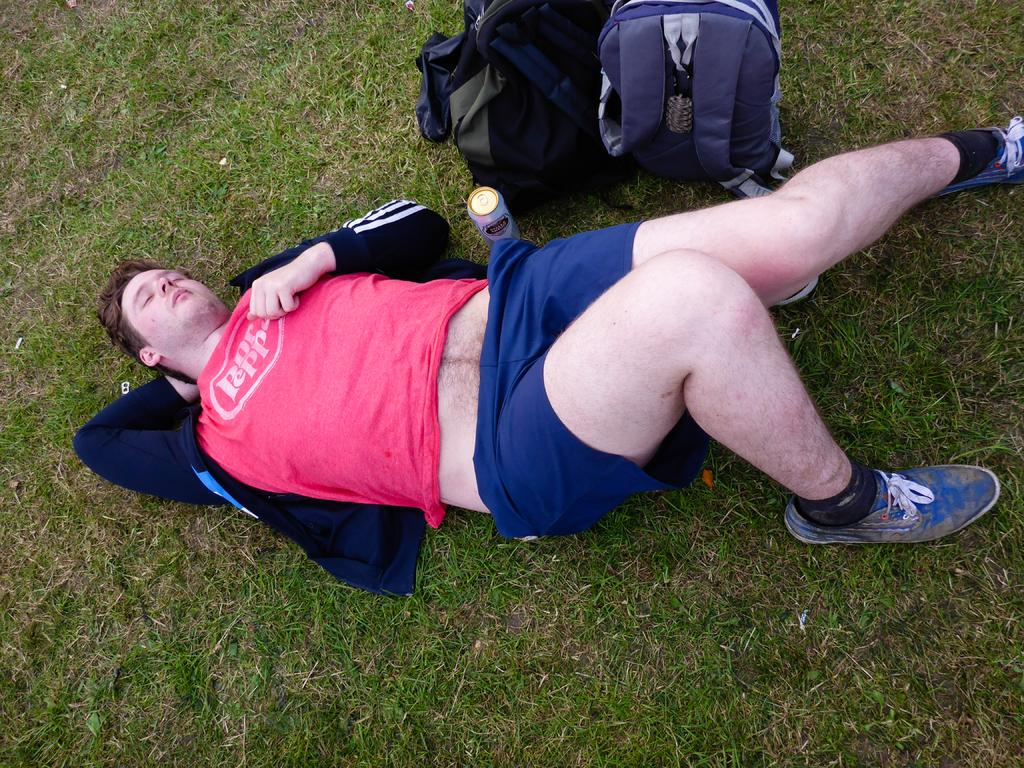What is the person in the image doing? The person is lying on the grass. What object is next to the person? There is a can beside the person. Are there any other items near the person? Yes, there are two bags beside the person. What type of ticket can be seen in the person's hand in the image? There is no ticket visible in the person's hand in the image. What kind of toad is hopping near the person in the image? There is no toad present in the image. 